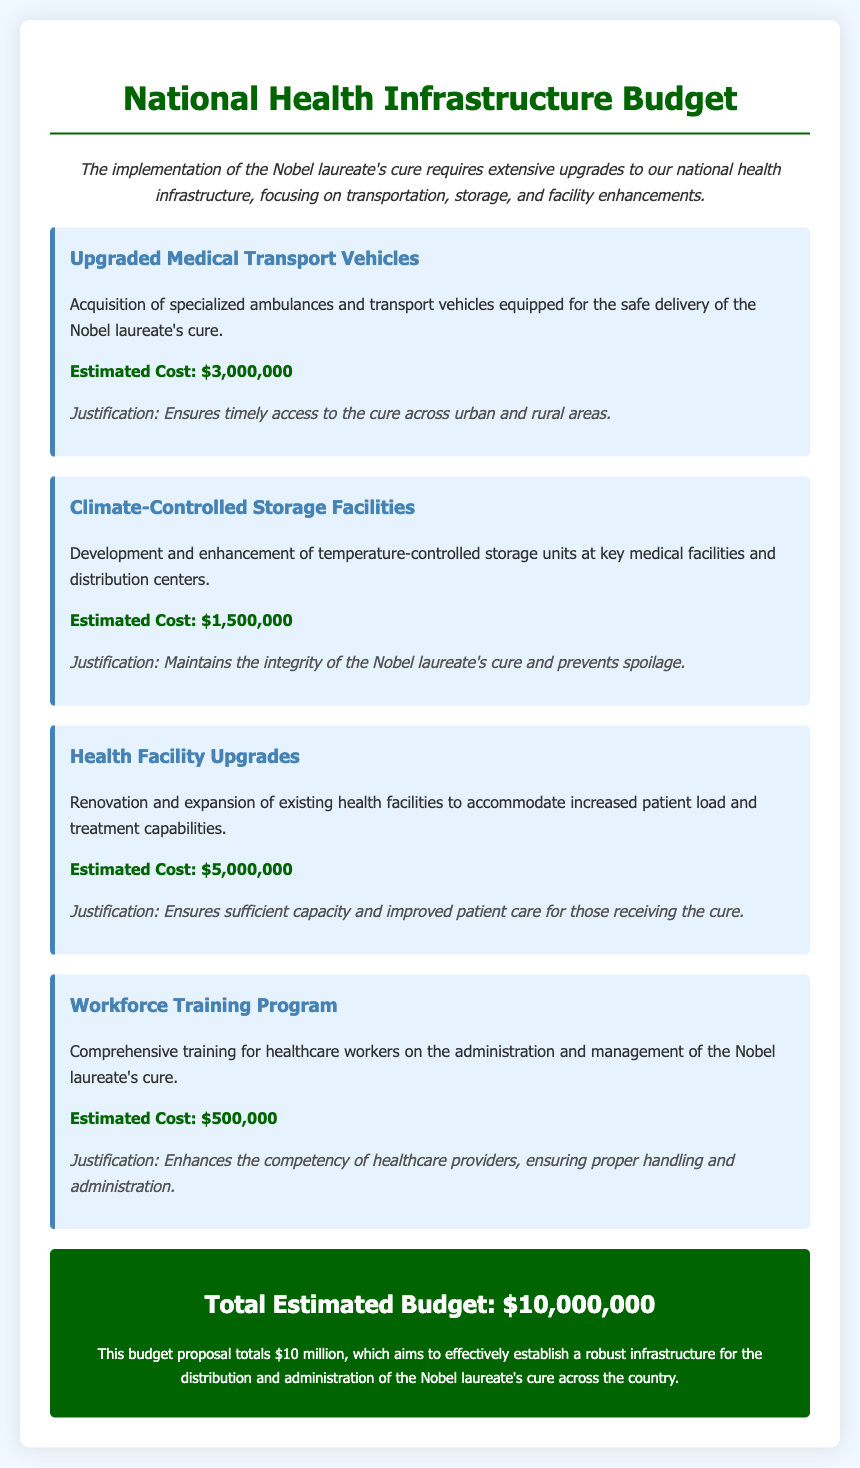What is the estimated cost for upgraded medical transport vehicles? The estimated cost for upgraded medical transport vehicles is explicitly stated in the document.
Answer: $3,000,000 What is the purpose of climate-controlled storage facilities? The document mentions that climate-controlled storage facilities are developed to maintain the integrity of the Nobel laureate's cure and prevent spoilage.
Answer: Maintain integrity What is the total estimated budget for the national health infrastructure upgrades? The total estimated budget is calculated from the summary presented in the document.
Answer: $10,000,000 How much is allocated for the workforce training program? The document provides a specific amount for the workforce training program that is directly mentioned.
Answer: $500,000 What is the justification for upgrading health facilities? The justification given in the document is intended to ensure sufficient capacity and improved patient care for those receiving the cure.
Answer: Sufficient capacity What budget item has the highest estimated cost? By comparing the costs listed in the document for each budget item, it can be identified.
Answer: Health Facility Upgrades What is the focus of the proposed upgrades in the budget? The document outlines the main focus areas for the proposed upgrades pertaining to the national health infrastructure.
Answer: Transportation, storage, and facilities How much is budgeted for climate-controlled storage facilities? The cost allocated for climate-controlled storage facilities is specifically indicated in the document.
Answer: $1,500,000 